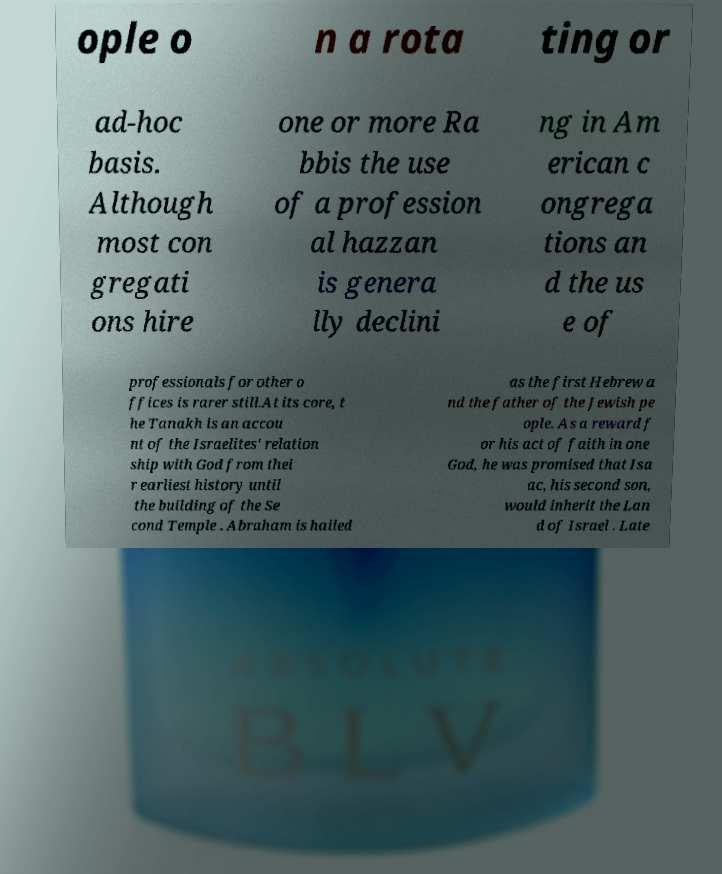Could you extract and type out the text from this image? ople o n a rota ting or ad-hoc basis. Although most con gregati ons hire one or more Ra bbis the use of a profession al hazzan is genera lly declini ng in Am erican c ongrega tions an d the us e of professionals for other o ffices is rarer still.At its core, t he Tanakh is an accou nt of the Israelites' relation ship with God from thei r earliest history until the building of the Se cond Temple . Abraham is hailed as the first Hebrew a nd the father of the Jewish pe ople. As a reward f or his act of faith in one God, he was promised that Isa ac, his second son, would inherit the Lan d of Israel . Late 